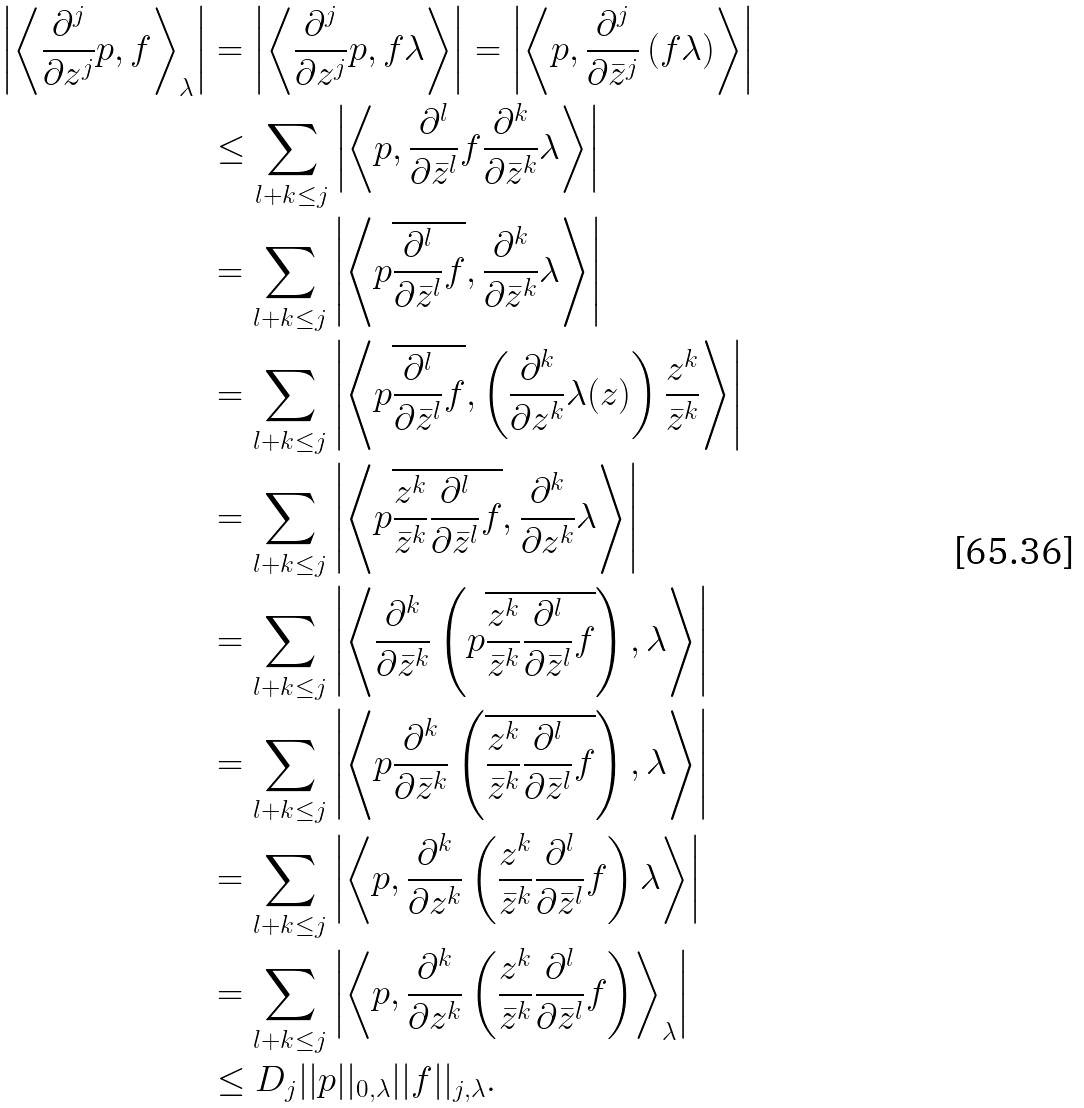<formula> <loc_0><loc_0><loc_500><loc_500>\left | \left < \frac { \partial ^ { j } } { \partial z ^ { j } } p , f \right > _ { \lambda } \right | & = \left | \left < \frac { \partial ^ { j } } { \partial z ^ { j } } p , f \lambda \right > \right | = \left | \left < p , \frac { \partial ^ { j } } { \partial \bar { z } ^ { j } } \left ( f \lambda \right ) \right > \right | \\ & \leq \sum _ { l + k \leq j } \left | \left < p , \frac { \partial ^ { l } } { \partial \bar { z } ^ { l } } f \frac { \partial ^ { k } } { \partial \bar { z } ^ { k } } \lambda \right > \right | \\ & = \sum _ { l + k \leq j } \left | \left < p \overline { \frac { \partial ^ { l } } { \partial \bar { z } ^ { l } } f } , \frac { \partial ^ { k } } { \partial \bar { z } ^ { k } } \lambda \right > \right | \\ & = \sum _ { l + k \leq j } \left | \left < p \overline { \frac { \partial ^ { l } } { \partial \bar { z } ^ { l } } f } , \left ( \frac { \partial ^ { k } } { \partial z ^ { k } } \lambda ( z ) \right ) \frac { z ^ { k } } { \bar { z } ^ { k } } \right > \right | \\ & = \sum _ { l + k \leq j } \left | \left < p \overline { \frac { z ^ { k } } { \bar { z } ^ { k } } \frac { \partial ^ { l } } { \partial \bar { z } ^ { l } } f } , \frac { \partial ^ { k } } { \partial z ^ { k } } \lambda \right > \right | \\ & = \sum _ { l + k \leq j } \left | \left < \frac { \partial ^ { k } } { \partial \bar { z } ^ { k } } \left ( p \overline { \frac { z ^ { k } } { \bar { z } ^ { k } } \frac { \partial ^ { l } } { \partial \bar { z } ^ { l } } f } \right ) , \lambda \right > \right | \\ & = \sum _ { l + k \leq j } \left | \left < p \frac { \partial ^ { k } } { \partial \bar { z } ^ { k } } \left ( \overline { \frac { z ^ { k } } { \bar { z } ^ { k } } \frac { \partial ^ { l } } { \partial \bar { z } ^ { l } } f } \right ) , \lambda \right > \right | \\ & = \sum _ { l + k \leq j } \left | \left < p , \frac { \partial ^ { k } } { \partial z ^ { k } } \left ( \frac { z ^ { k } } { \bar { z } ^ { k } } \frac { \partial ^ { l } } { \partial \bar { z } ^ { l } } f \right ) \lambda \right > \right | \\ & = \sum _ { l + k \leq j } \left | \left < p , \frac { \partial ^ { k } } { \partial z ^ { k } } \left ( \frac { z ^ { k } } { \bar { z } ^ { k } } \frac { \partial ^ { l } } { \partial \bar { z } ^ { l } } f \right ) \right > _ { \lambda } \right | \\ & \leq D _ { j } | | p | | _ { 0 , \lambda } | | f | | _ { j , \lambda } .</formula> 